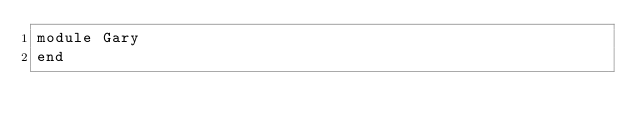Convert code to text. <code><loc_0><loc_0><loc_500><loc_500><_Ruby_>module Gary
end
</code> 